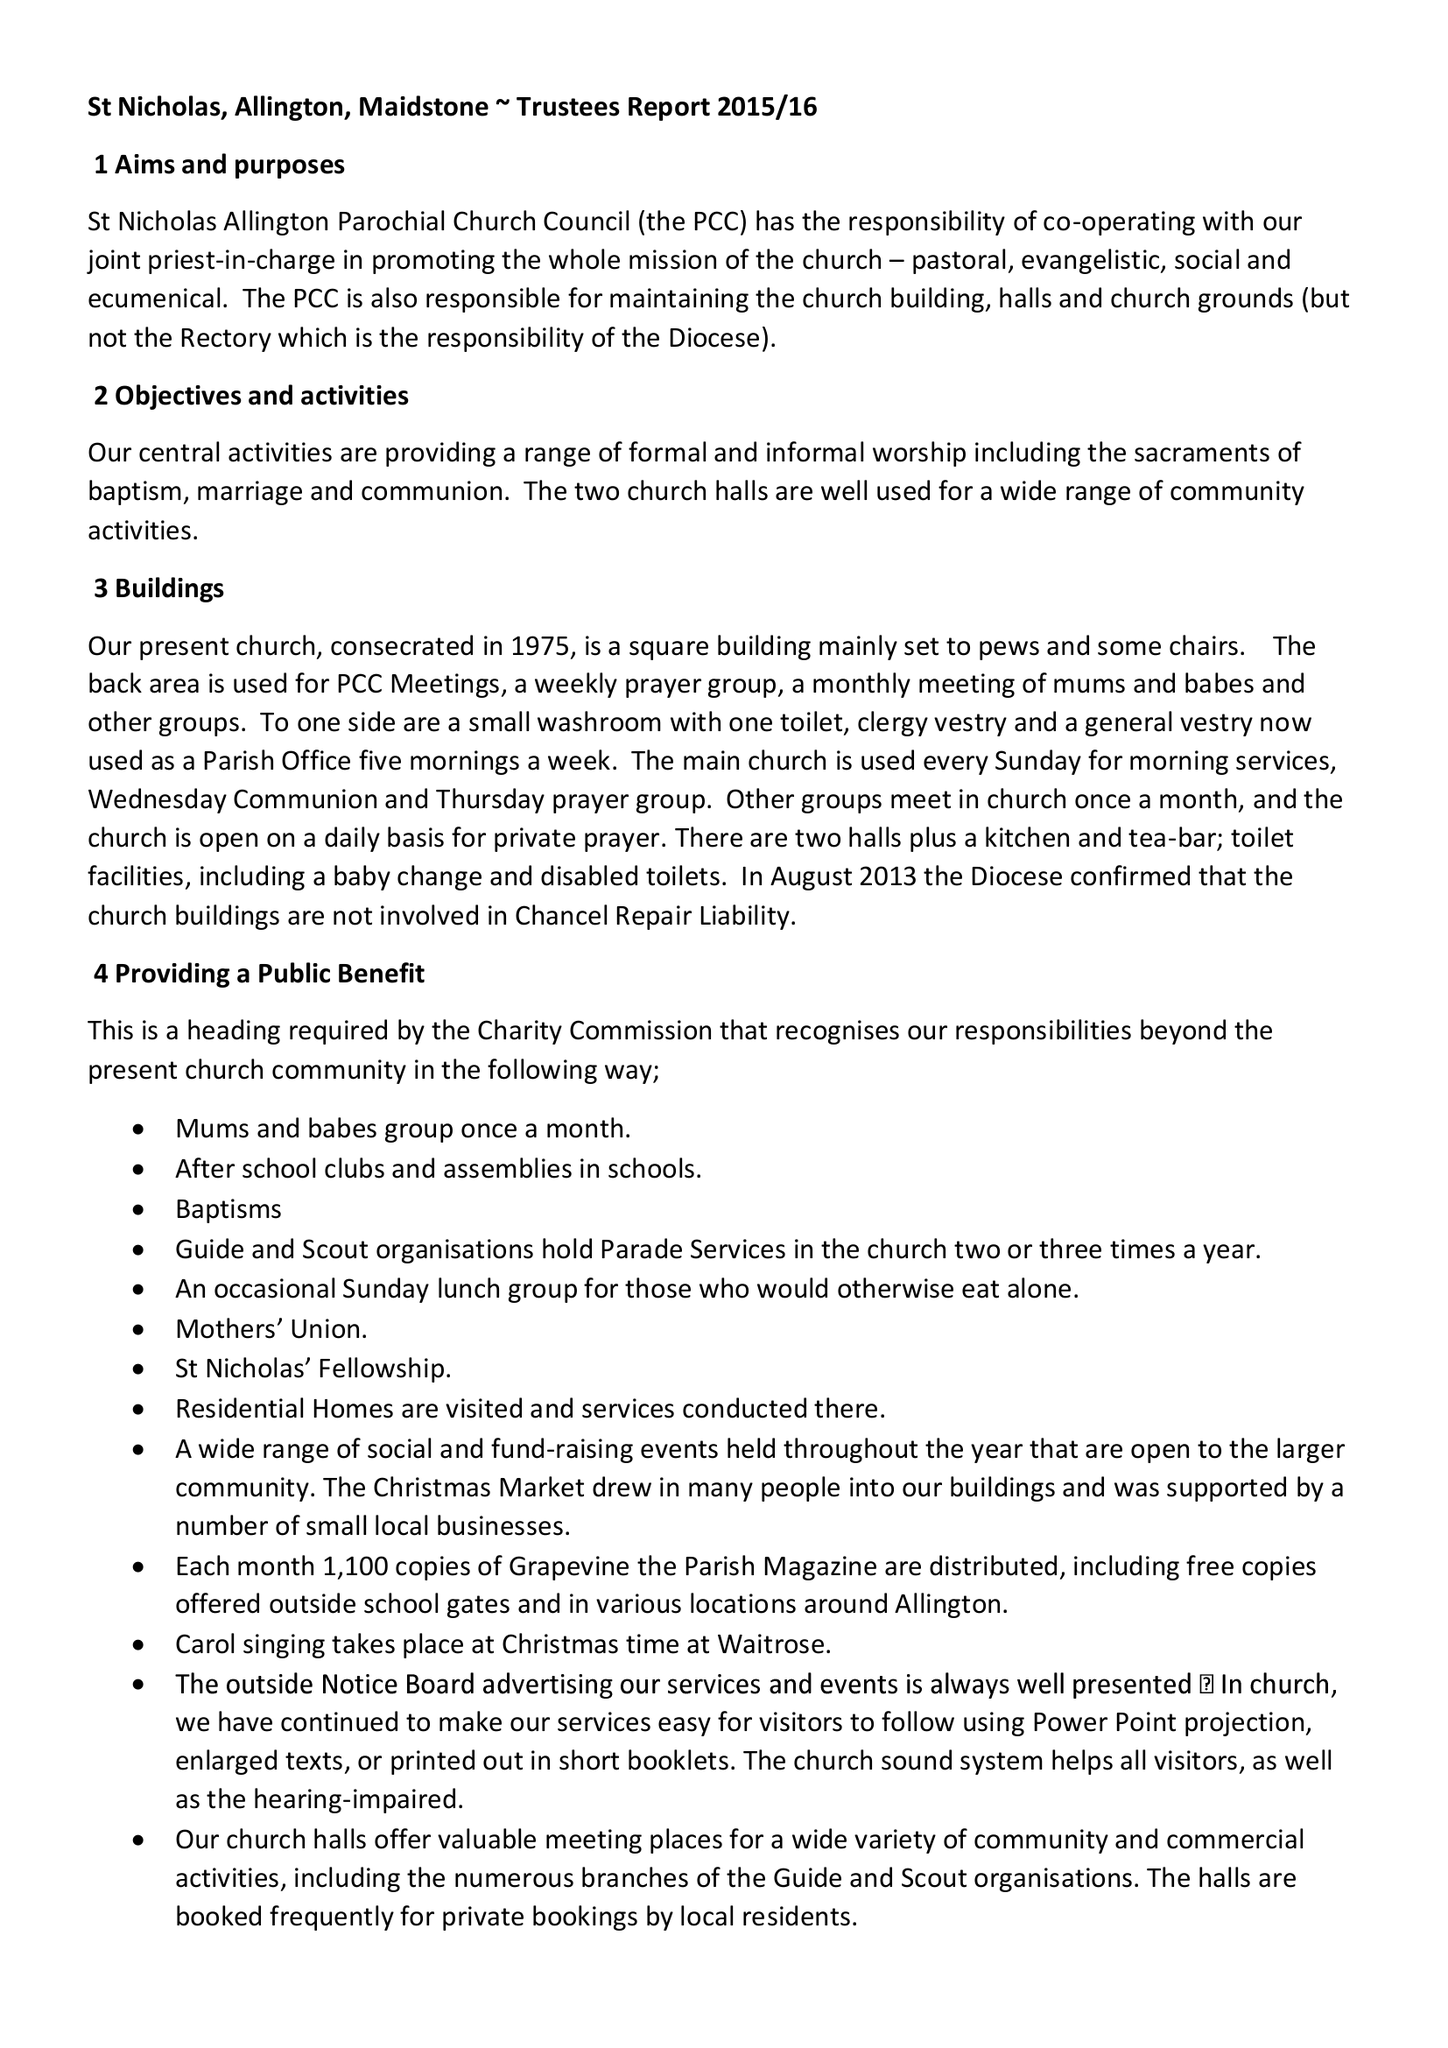What is the value for the address__postcode?
Answer the question using a single word or phrase. ME16 0DE 